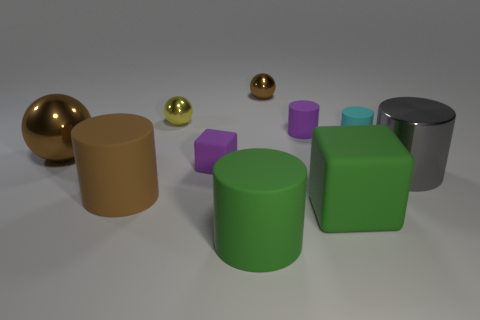Subtract all brown balls. How many were subtracted if there are1brown balls left? 1 Subtract all brown cylinders. How many cylinders are left? 4 Subtract all big brown rubber cylinders. How many cylinders are left? 4 Subtract all cyan spheres. Subtract all blue cubes. How many spheres are left? 3 Subtract all blocks. How many objects are left? 8 Add 4 blue balls. How many blue balls exist? 4 Subtract 1 cyan cylinders. How many objects are left? 9 Subtract all big green shiny cylinders. Subtract all big things. How many objects are left? 5 Add 5 brown objects. How many brown objects are left? 8 